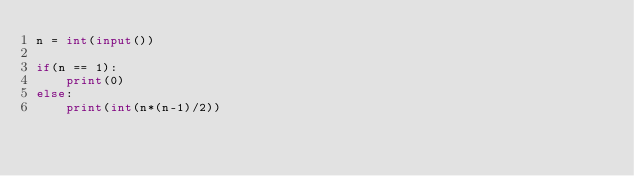Convert code to text. <code><loc_0><loc_0><loc_500><loc_500><_Python_>n = int(input())

if(n == 1):
    print(0)
else:
    print(int(n*(n-1)/2))</code> 